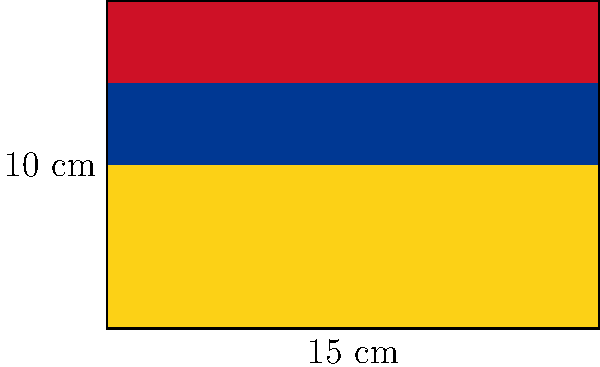A rectangular flag inspired by the Colombian flag's colors is designed with a length of 15 cm and a width of 10 cm. The flag is divided into three horizontal stripes: yellow (50% of the total area), blue (25% of the total area), and red (25% of the total area), from bottom to top. Calculate the area of the blue stripe in square centimeters. To find the area of the blue stripe, we'll follow these steps:

1. Calculate the total area of the flag:
   $A_{total} = length \times width = 15 \text{ cm} \times 10 \text{ cm} = 150 \text{ cm}^2$

2. Determine the area of the blue stripe:
   The blue stripe occupies 25% of the total area.
   $A_{blue} = 25\% \times A_{total} = 0.25 \times 150 \text{ cm}^2 = 37.5 \text{ cm}^2$

Therefore, the area of the blue stripe is 37.5 square centimeters.
Answer: $37.5 \text{ cm}^2$ 